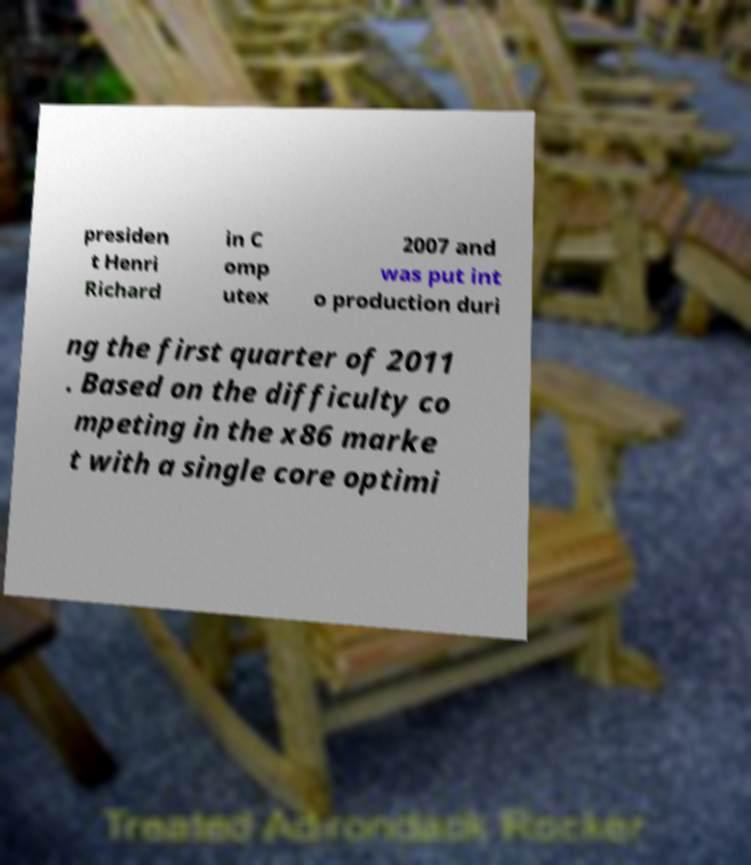Could you assist in decoding the text presented in this image and type it out clearly? presiden t Henri Richard in C omp utex 2007 and was put int o production duri ng the first quarter of 2011 . Based on the difficulty co mpeting in the x86 marke t with a single core optimi 